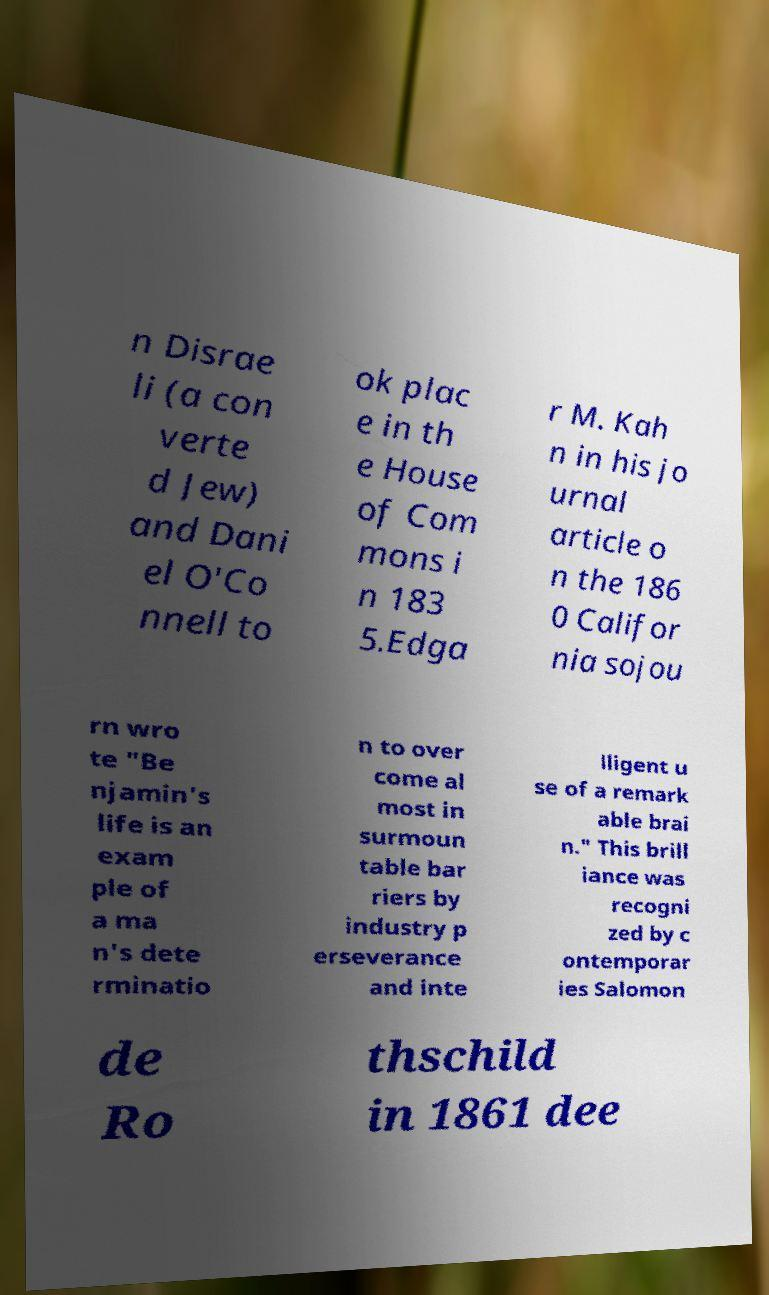Please identify and transcribe the text found in this image. n Disrae li (a con verte d Jew) and Dani el O'Co nnell to ok plac e in th e House of Com mons i n 183 5.Edga r M. Kah n in his jo urnal article o n the 186 0 Califor nia sojou rn wro te "Be njamin's life is an exam ple of a ma n's dete rminatio n to over come al most in surmoun table bar riers by industry p erseverance and inte lligent u se of a remark able brai n." This brill iance was recogni zed by c ontemporar ies Salomon de Ro thschild in 1861 dee 